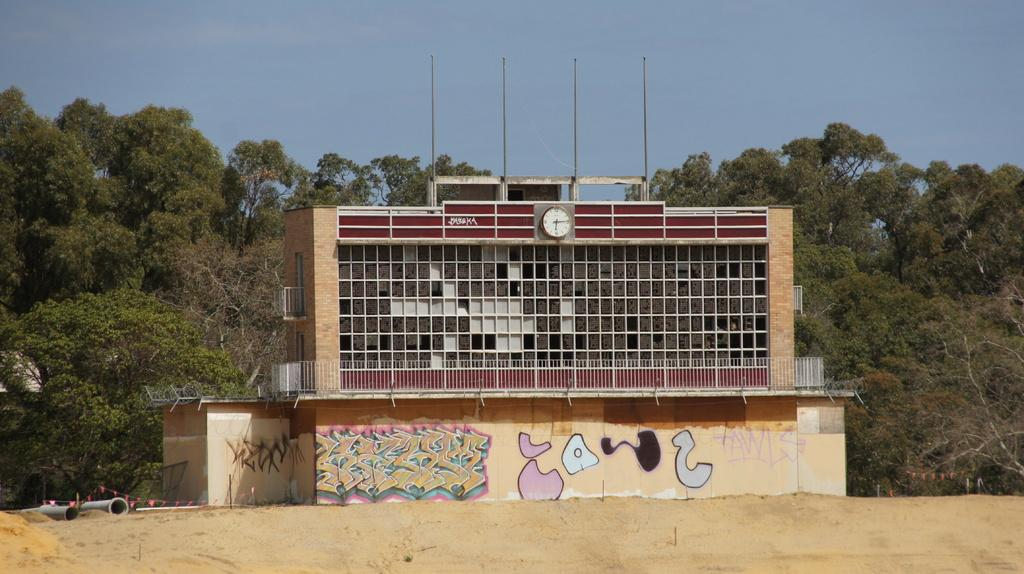What is the main structure in the center of the image? There is a building in the center of the image. What can be seen in the background of the image? There are trees in the background of the image. What is visible at the top of the image? The sky is visible at the top of the image. What materials are present at the bottom of the image? Pipes and sand are visible at the bottom of the image. How many apples are being used to play a game of cards in the image? There are no apples or cards present in the image. 